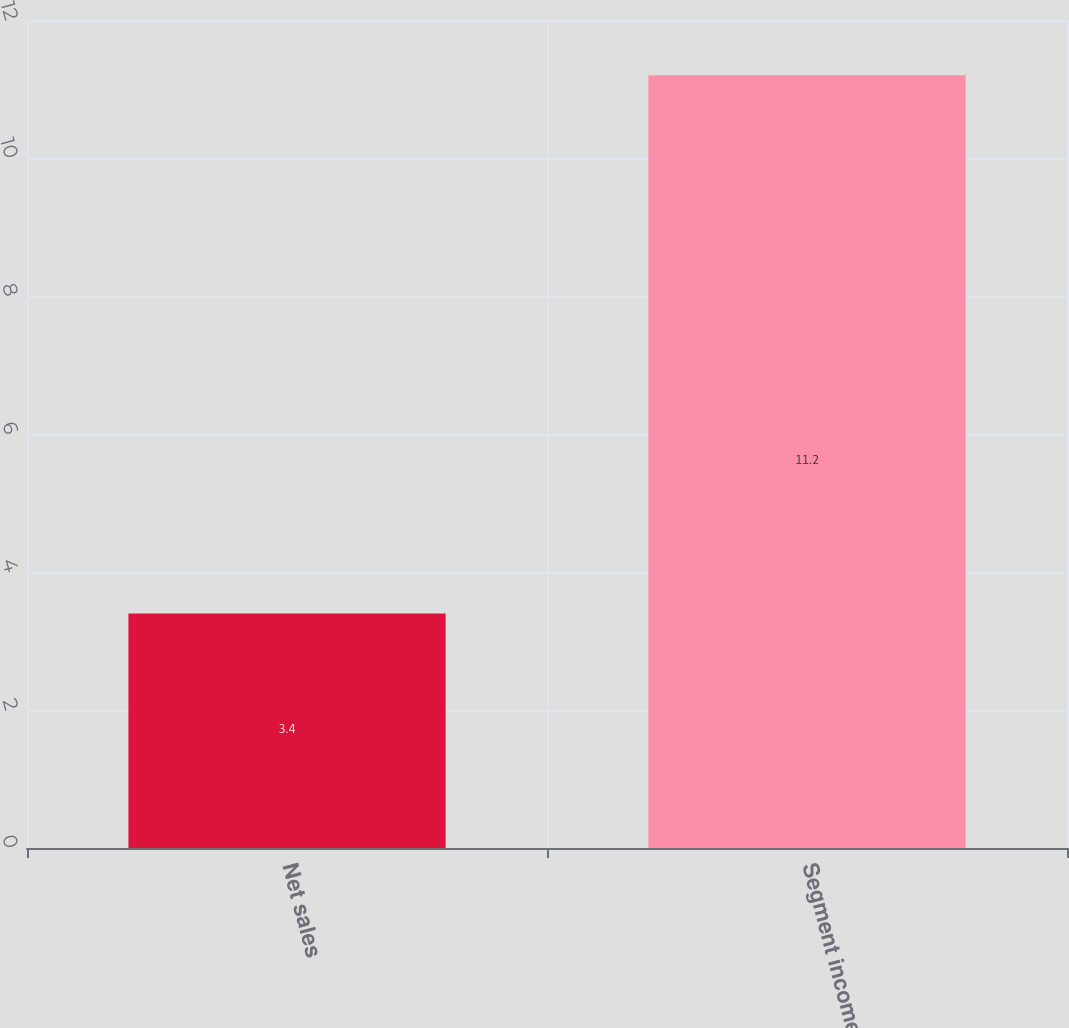<chart> <loc_0><loc_0><loc_500><loc_500><bar_chart><fcel>Net sales<fcel>Segment income<nl><fcel>3.4<fcel>11.2<nl></chart> 